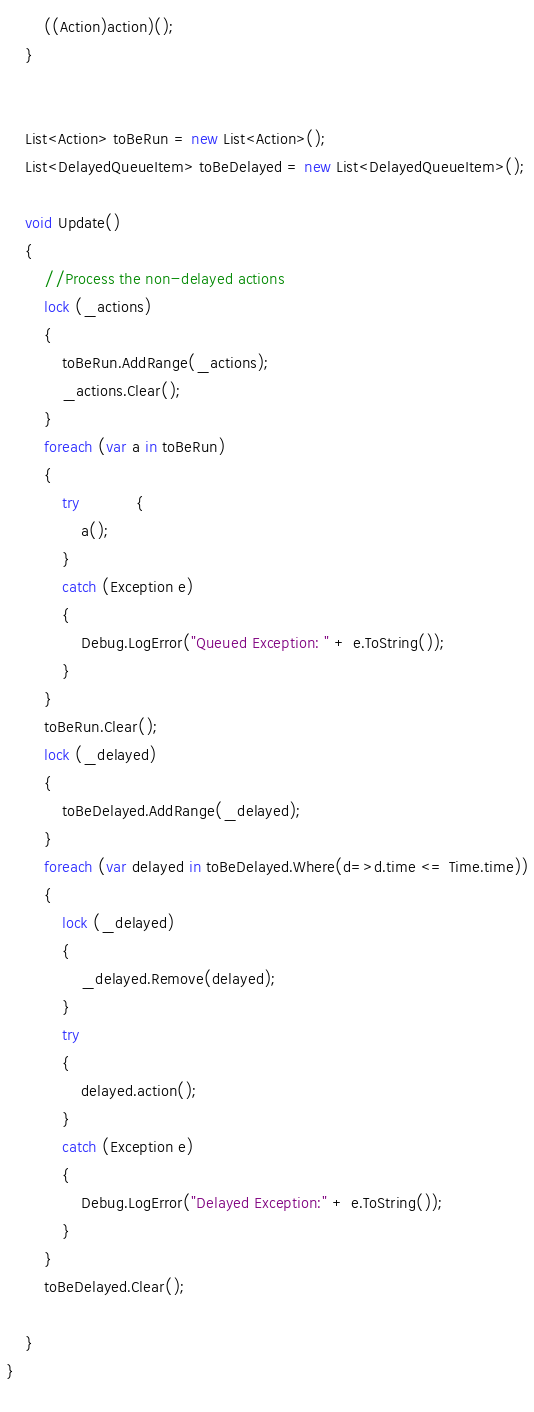Convert code to text. <code><loc_0><loc_0><loc_500><loc_500><_C#_>		((Action)action)();
	}
	
				
	List<Action> toBeRun = new List<Action>();
	List<DelayedQueueItem> toBeDelayed = new List<DelayedQueueItem>();
	
	void Update()
	{
		//Process the non-delayed actions
		lock (_actions)
		{
			toBeRun.AddRange(_actions);
			_actions.Clear();
		}
		foreach (var a in toBeRun)
		{
			try			{
				a();
			}
			catch (Exception e)
			{
				Debug.LogError("Queued Exception: " + e.ToString());
			}
		}
		toBeRun.Clear();
		lock (_delayed)
		{
			toBeDelayed.AddRange(_delayed);
		}
		foreach (var delayed in toBeDelayed.Where(d=>d.time <= Time.time))
		{
			lock (_delayed)
			{
				_delayed.Remove(delayed);
			}
			try
			{
				delayed.action();
			}
			catch (Exception e)
			{
				Debug.LogError("Delayed Exception:" + e.ToString());
			}
		}
		toBeDelayed.Clear();
					
	}
}
		
</code> 